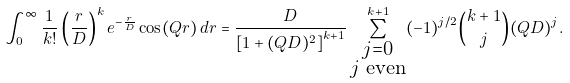<formula> <loc_0><loc_0><loc_500><loc_500>\int _ { 0 } ^ { \infty } \frac { 1 } { k ! } \left ( \frac { r } { D } \right ) ^ { k } e ^ { - \frac { r } { D } } \cos ( Q r ) \, d r = \frac { D } { \left [ 1 + ( Q D ) ^ { 2 } \right ] ^ { k + 1 } } \sum _ { \substack { j = 0 \\ j \text { even} } } ^ { k + 1 } ( - 1 ) ^ { j / 2 } \binom { k + 1 } { j } ( Q D ) ^ { j } .</formula> 